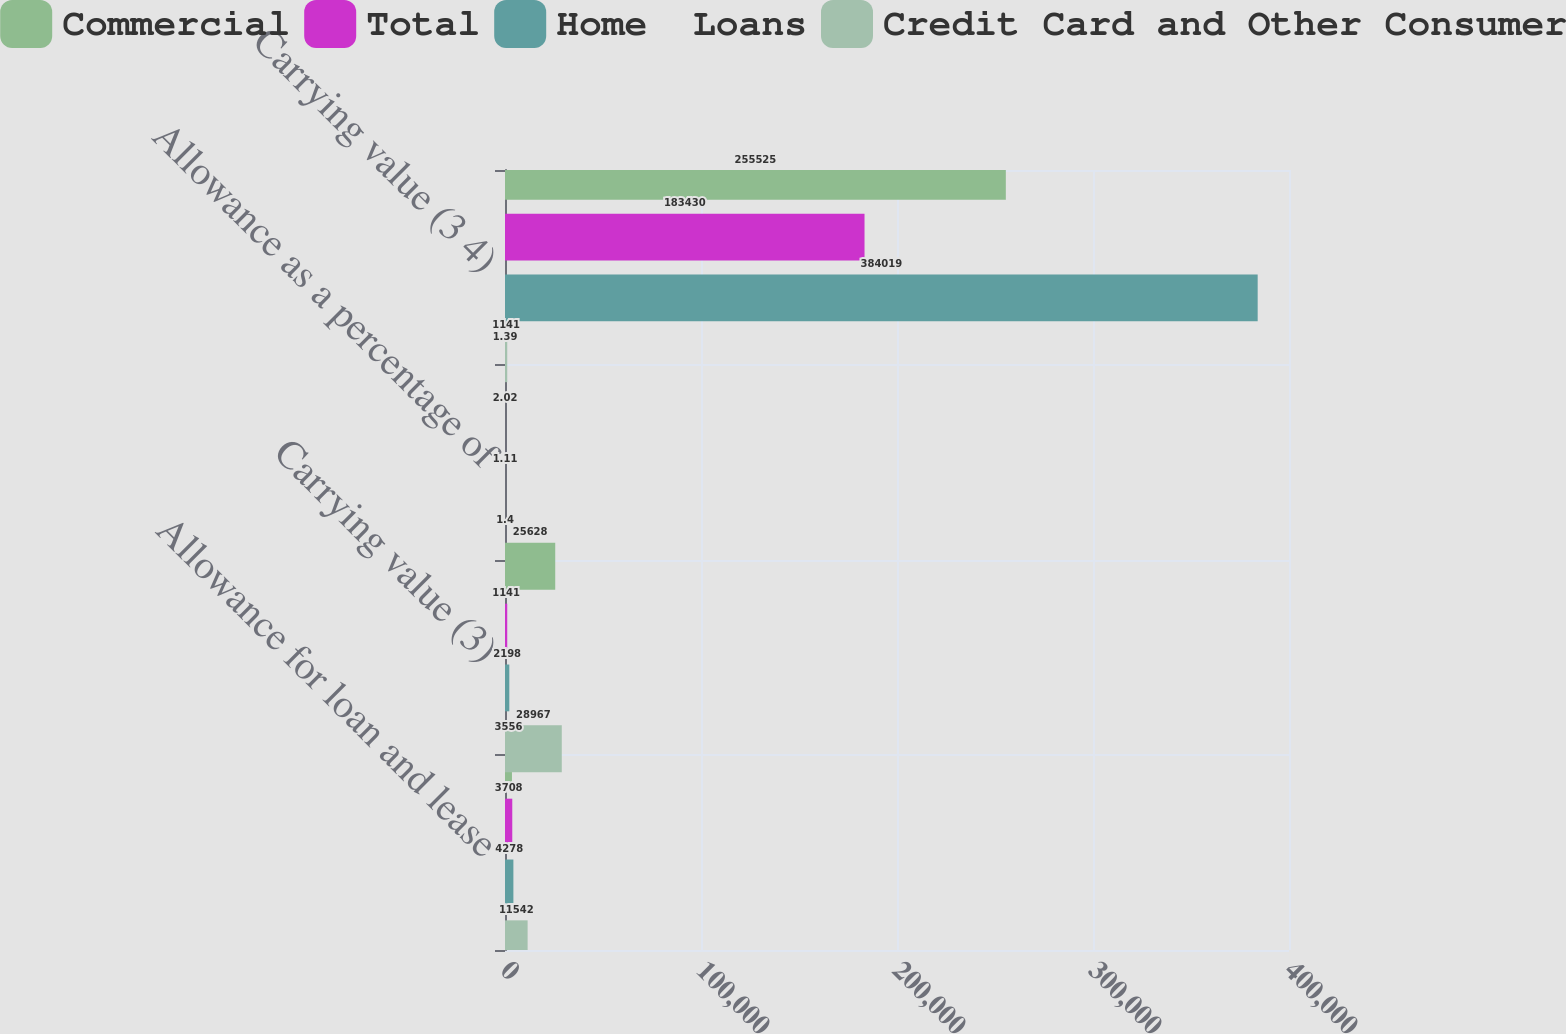Convert chart. <chart><loc_0><loc_0><loc_500><loc_500><stacked_bar_chart><ecel><fcel>Allowance for loan and lease<fcel>Carrying value (3)<fcel>Allowance as a percentage of<fcel>Carrying value (3 4)<nl><fcel>Commercial<fcel>3556<fcel>25628<fcel>1.39<fcel>255525<nl><fcel>Total<fcel>3708<fcel>1141<fcel>2.02<fcel>183430<nl><fcel>Home  Loans<fcel>4278<fcel>2198<fcel>1.11<fcel>384019<nl><fcel>Credit Card and Other Consumer<fcel>11542<fcel>28967<fcel>1.4<fcel>1141<nl></chart> 